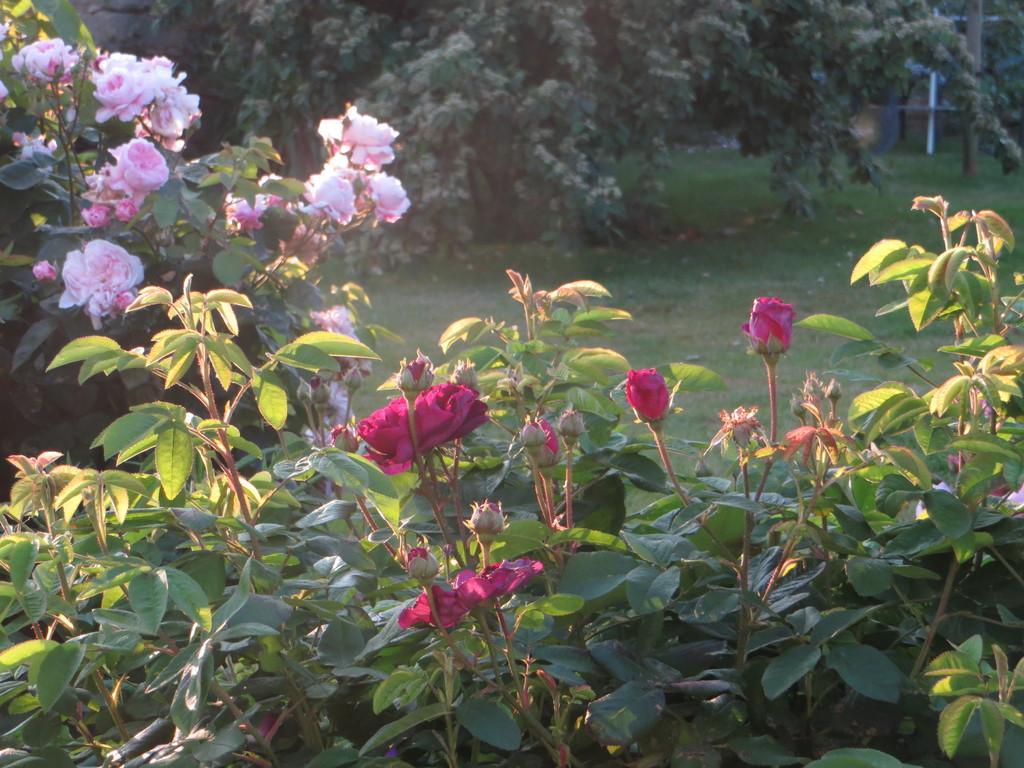Please provide a concise description of this image. In the image in the center we can see trees,plants,grass and flowers in different colors. 